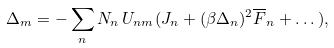<formula> <loc_0><loc_0><loc_500><loc_500>\Delta _ { m } = - \sum _ { n } N _ { n } \, U _ { n m } ( J _ { n } + ( \beta \Delta _ { n } ) ^ { 2 } \overline { F } _ { n } + \dots ) ,</formula> 